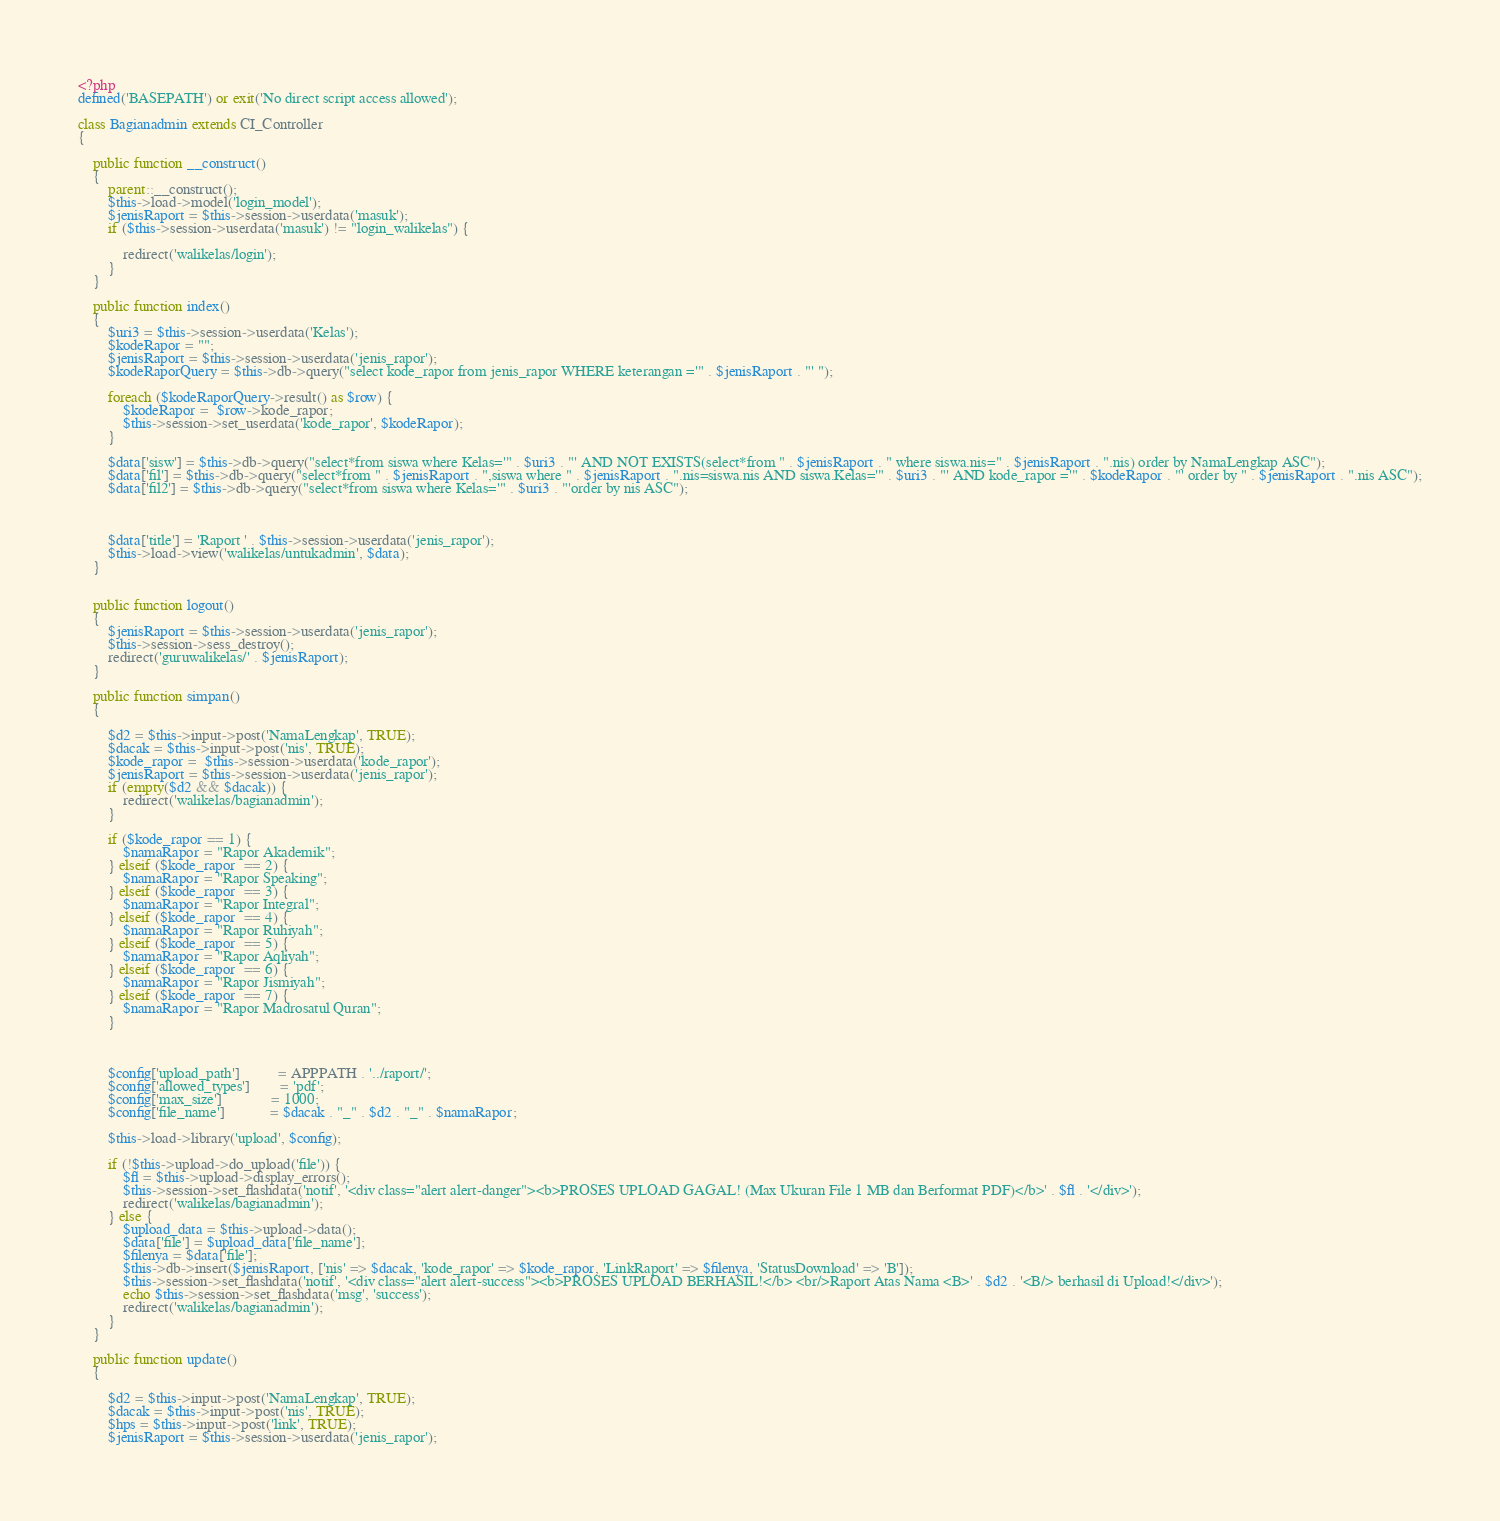Convert code to text. <code><loc_0><loc_0><loc_500><loc_500><_PHP_><?php
defined('BASEPATH') or exit('No direct script access allowed');

class Bagianadmin extends CI_Controller
{

    public function __construct()
    {
        parent::__construct();
        $this->load->model('login_model');
        $jenisRaport = $this->session->userdata('masuk');
        if ($this->session->userdata('masuk') != "login_walikelas") {

            redirect('walikelas/login');
        }
    }

    public function index()
    {
        $uri3 = $this->session->userdata('Kelas');
        $kodeRapor = "";
        $jenisRaport = $this->session->userdata('jenis_rapor');
        $kodeRaporQuery = $this->db->query("select kode_rapor from jenis_rapor WHERE keterangan ='" . $jenisRaport . "' ");

        foreach ($kodeRaporQuery->result() as $row) {
            $kodeRapor =  $row->kode_rapor;
            $this->session->set_userdata('kode_rapor', $kodeRapor);
        }

        $data['sisw'] = $this->db->query("select*from siswa where Kelas='" . $uri3 . "' AND NOT EXISTS(select*from " . $jenisRaport . " where siswa.nis=" . $jenisRaport . ".nis) order by NamaLengkap ASC");
        $data['fil'] = $this->db->query("select*from " . $jenisRaport . ",siswa where " . $jenisRaport . ".nis=siswa.nis AND siswa.Kelas='" . $uri3 . "' AND kode_rapor ='" . $kodeRapor . "' order by " . $jenisRaport . ".nis ASC");
        $data['fil2'] = $this->db->query("select*from siswa where Kelas='" . $uri3 . "'order by nis ASC");



        $data['title'] = 'Raport ' . $this->session->userdata('jenis_rapor');
        $this->load->view('walikelas/untukadmin', $data);
    }


    public function logout()
    {
        $jenisRaport = $this->session->userdata('jenis_rapor');
        $this->session->sess_destroy();
        redirect('guruwalikelas/' . $jenisRaport);
    }

    public function simpan()
    {

        $d2 = $this->input->post('NamaLengkap', TRUE);
        $dacak = $this->input->post('nis', TRUE);
        $kode_rapor =  $this->session->userdata('kode_rapor');
        $jenisRaport = $this->session->userdata('jenis_rapor');
        if (empty($d2 && $dacak)) {
            redirect('walikelas/bagianadmin');
        }

        if ($kode_rapor == 1) {
            $namaRapor = "Rapor Akademik";
        } elseif ($kode_rapor  == 2) {
            $namaRapor = "Rapor Speaking";
        } elseif ($kode_rapor  == 3) {
            $namaRapor = "Rapor Integral";
        } elseif ($kode_rapor  == 4) {
            $namaRapor = "Rapor Ruhiyah";
        } elseif ($kode_rapor  == 5) {
            $namaRapor = "Rapor Aqliyah";
        } elseif ($kode_rapor  == 6) {
            $namaRapor = "Rapor Jismiyah";
        } elseif ($kode_rapor  == 7) {
            $namaRapor = "Rapor Madrosatul Quran";
        }



        $config['upload_path']          = APPPATH . '../raport/';
        $config['allowed_types']        = 'pdf';
        $config['max_size']             = 1000;
        $config['file_name']            = $dacak . "_" . $d2 . "_" . $namaRapor;

        $this->load->library('upload', $config);

        if (!$this->upload->do_upload('file')) {
            $fl = $this->upload->display_errors();
            $this->session->set_flashdata('notif', '<div class="alert alert-danger"><b>PROSES UPLOAD GAGAL! (Max Ukuran File 1 MB dan Berformat PDF)</b>' . $fl . '</div>');
            redirect('walikelas/bagianadmin');
        } else {
            $upload_data = $this->upload->data();
            $data['file'] = $upload_data['file_name'];
            $filenya = $data['file'];
            $this->db->insert($jenisRaport, ['nis' => $dacak, 'kode_rapor' => $kode_rapor, 'LinkRaport' => $filenya, 'StatusDownload' => 'B']);
            $this->session->set_flashdata('notif', '<div class="alert alert-success"><b>PROSES UPLOAD BERHASIL!</b> <br/>Raport Atas Nama <B>' . $d2 . '<B/> berhasil di Upload!</div>');
            echo $this->session->set_flashdata('msg', 'success');
            redirect('walikelas/bagianadmin');
        }
    }

    public function update()
    {

        $d2 = $this->input->post('NamaLengkap', TRUE);
        $dacak = $this->input->post('nis', TRUE);
        $hps = $this->input->post('link', TRUE);
        $jenisRaport = $this->session->userdata('jenis_rapor');</code> 